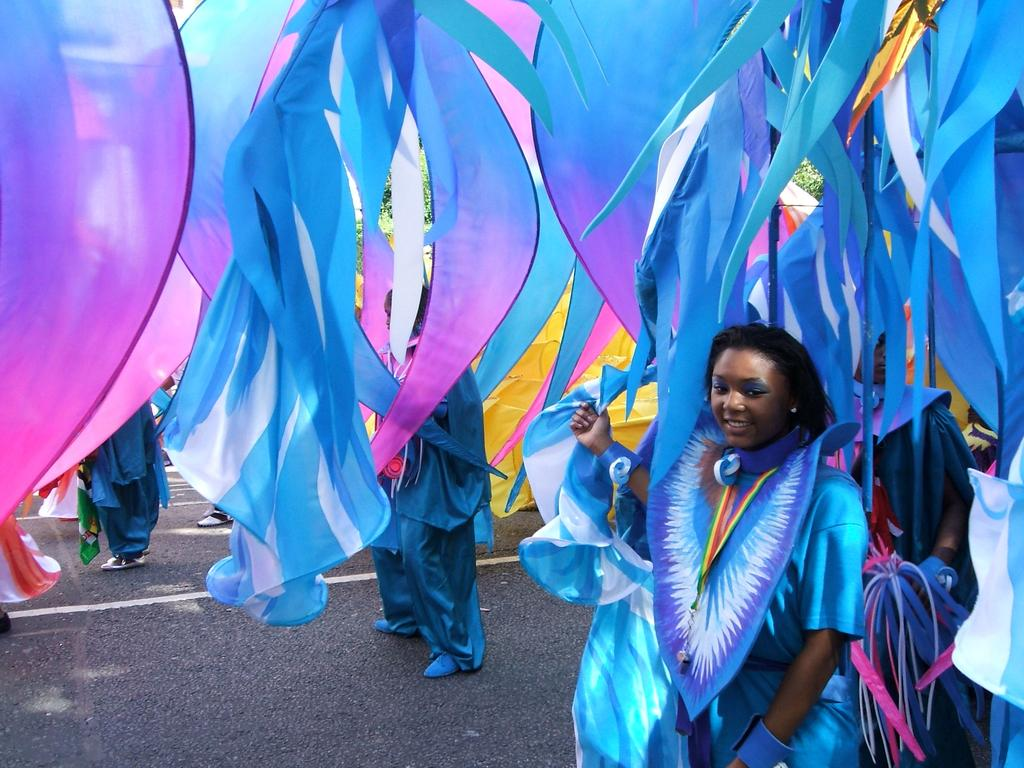What are the people in the image wearing? The people in the image are wearing costumes. What can be seen in the background of the image? There are streamers in the background of the image. What is visible at the bottom of the image? There is a road visible at the bottom of the image. What type of watch is the person wearing in the image? There is no watch visible on any of the people in the image. 